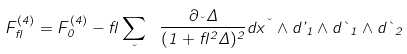<formula> <loc_0><loc_0><loc_500><loc_500>F ^ { ( 4 ) } _ { \gamma } = F ^ { ( 4 ) } _ { 0 } - \gamma \sum _ { \kappa } \ \frac { \partial _ { \kappa } \Delta } { ( 1 + \gamma ^ { 2 } \Delta ) ^ { 2 } } d x ^ { \kappa } \wedge d \varphi _ { 1 } \wedge d \theta _ { 1 } \wedge d \theta _ { 2 }</formula> 